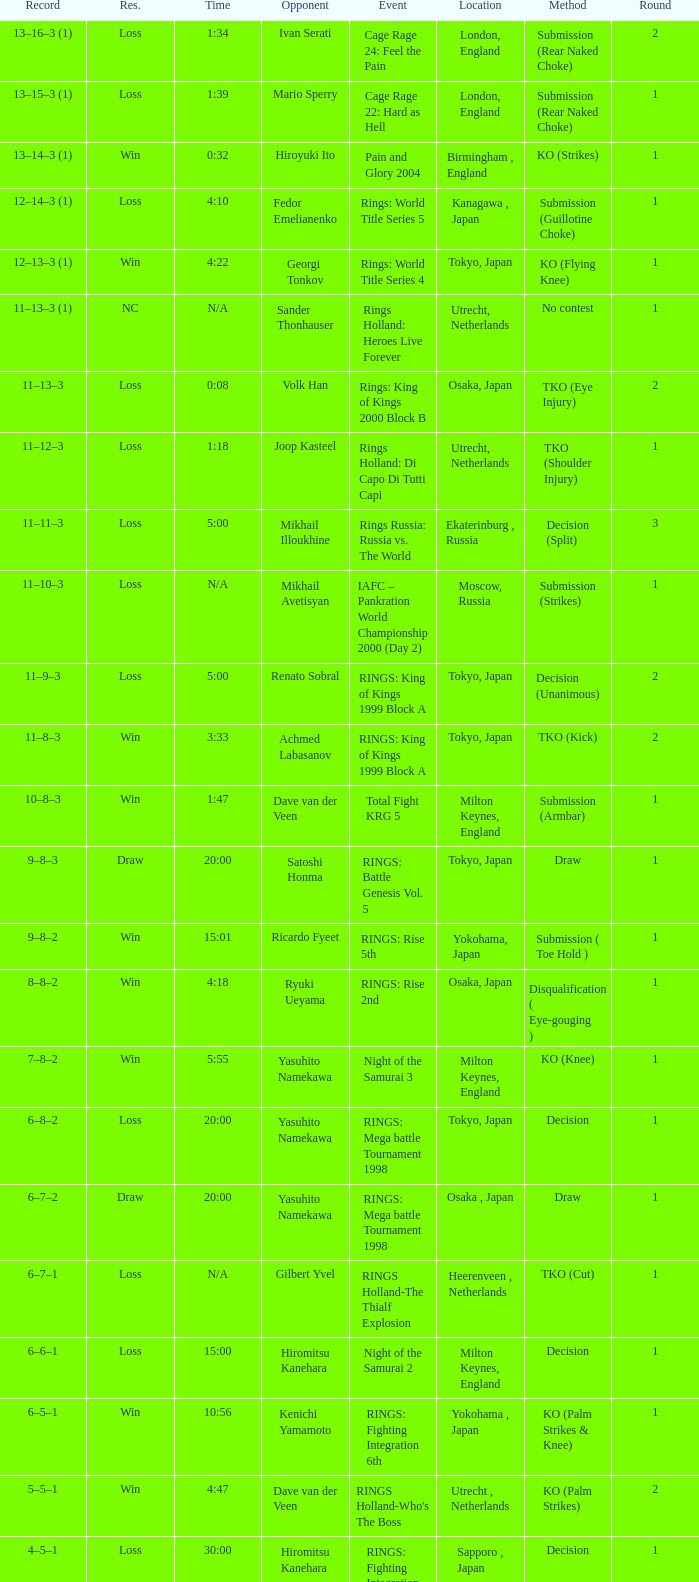What is the time for Moscow, Russia? N/A. 